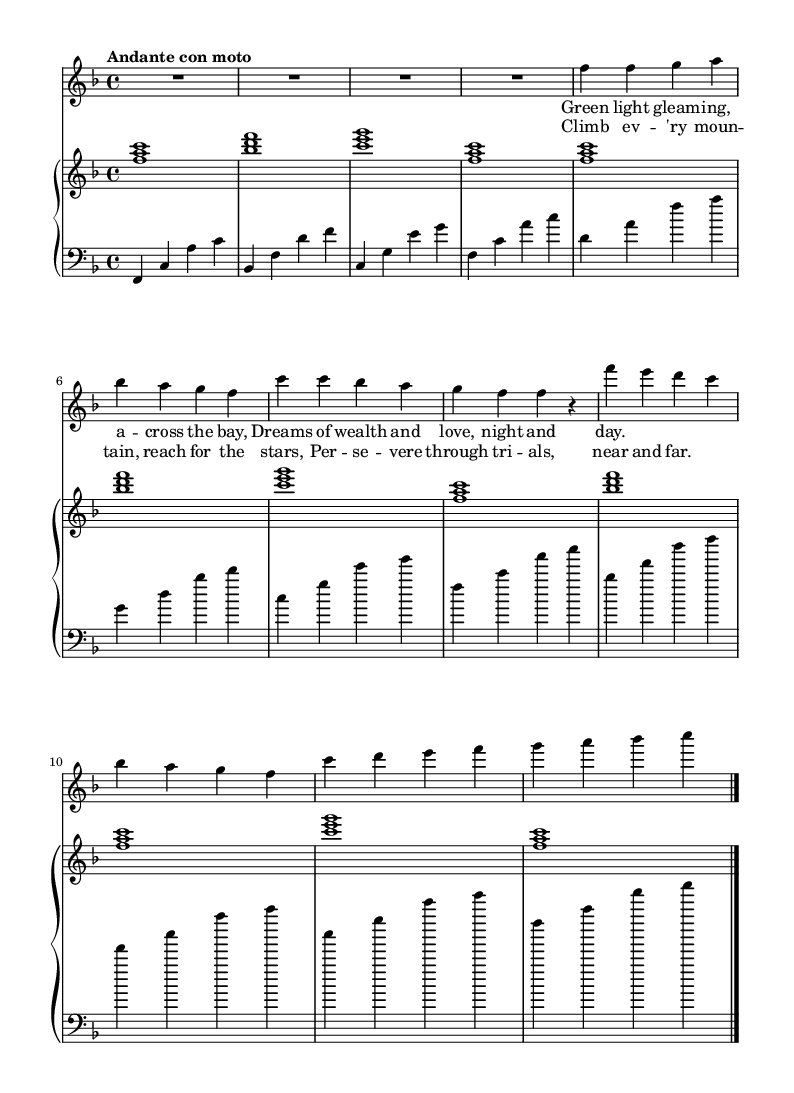What is the key signature of this music? The key signature displayed at the beginning of the staff indicates F major, which is identified by one flat (B flat).
Answer: F major What is the time signature of this piece? The time signature shown at the beginning is 4/4, which means there are four beats per measure and the quarter note receives one beat.
Answer: 4/4 What is the tempo marking? The tempo marking at the beginning indicates "Andante con moto," suggesting a moderately slow tempo with some movement.
Answer: Andante con moto How many measures are there in the soprano part? By counting the distinct segments divided by the bar lines in the soprano part, there are a total of 8 measures.
Answer: 8 What type of musical texture is primarily showcased in this piece? The piece features a combination of voices (soprano) with harmonic accompaniment from the piano, indicating a homophonic texture.
Answer: Homophonic Which literary theme is prominently expressed in the lyrics? The lyrics highlight themes of ambition and perseverance through references to climbing mountains and reaching for dreams.
Answer: Ambition and perseverance What is the role of the chorus in this operatic adaptation? The chorus reinforces the main themes by emphasizing perseverance and aspiration, creating a collective voice that supports the narrative.
Answer: Reinforcement of themes 